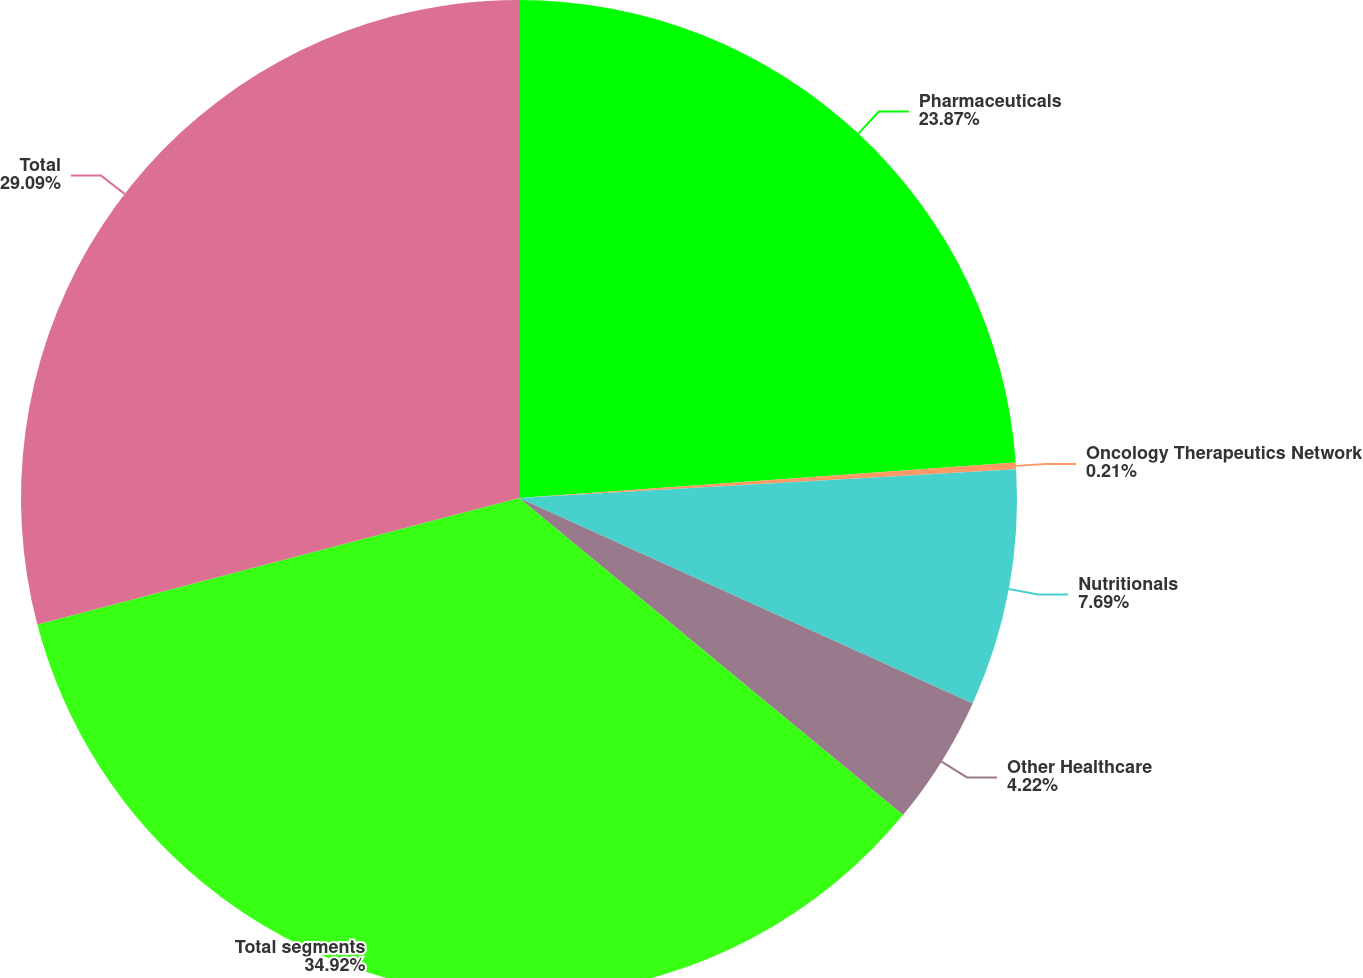<chart> <loc_0><loc_0><loc_500><loc_500><pie_chart><fcel>Pharmaceuticals<fcel>Oncology Therapeutics Network<fcel>Nutritionals<fcel>Other Healthcare<fcel>Total segments<fcel>Total<nl><fcel>23.87%<fcel>0.21%<fcel>7.69%<fcel>4.22%<fcel>34.93%<fcel>29.09%<nl></chart> 